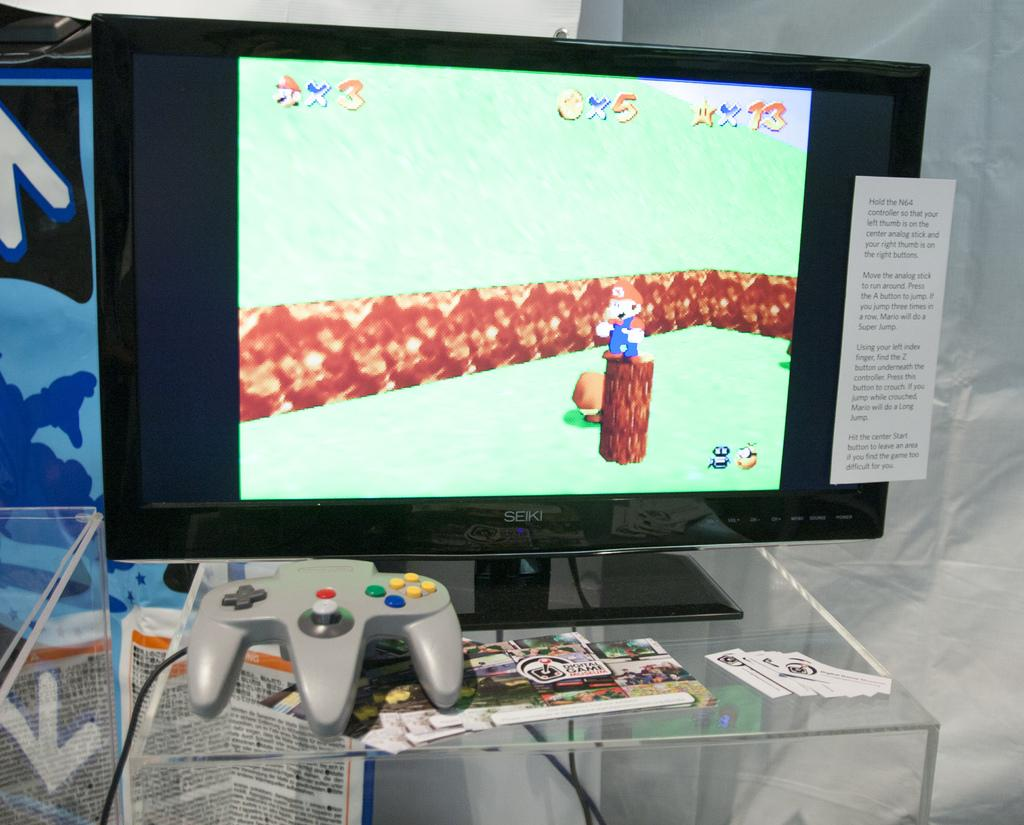<image>
Present a compact description of the photo's key features. a game where there is a X3 on the top 